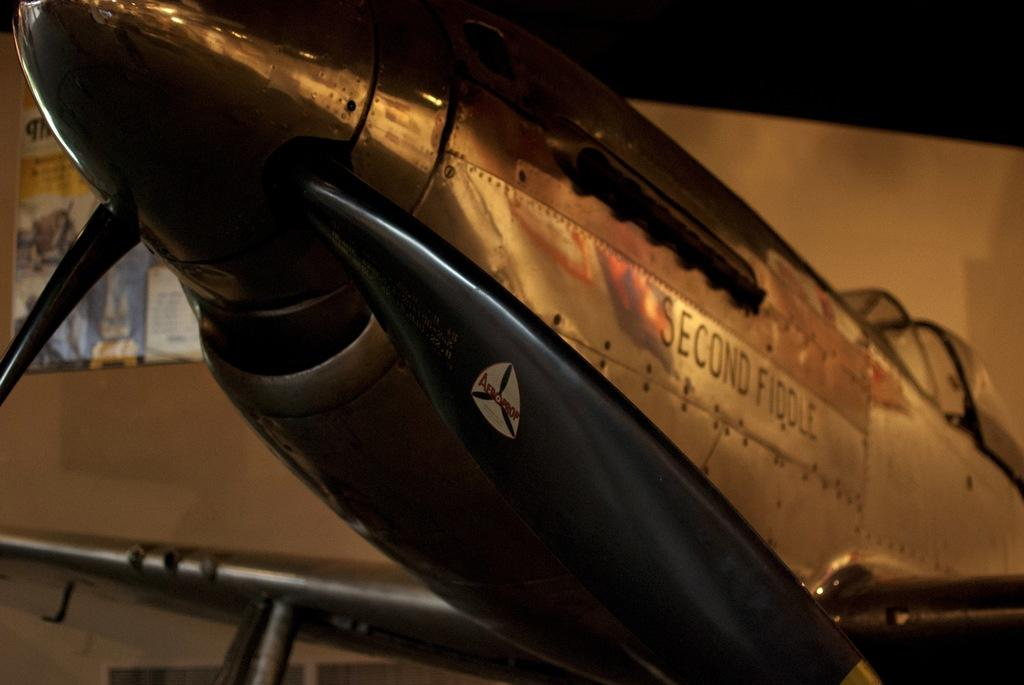<image>
Describe the image concisely. the nose section of a plane reads Second Fiddle on it 